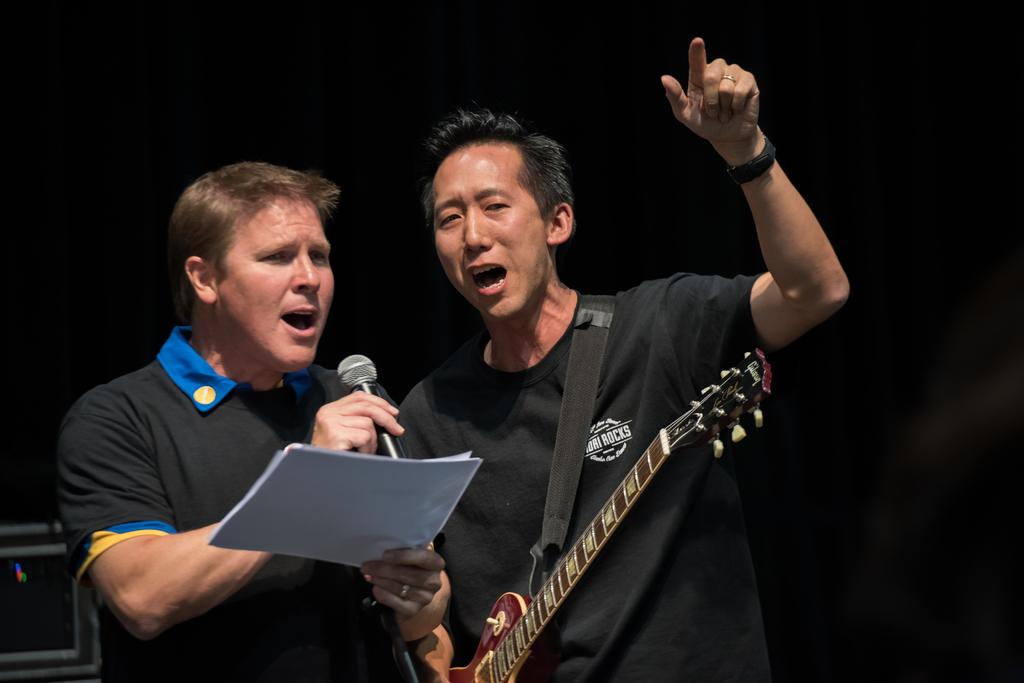Who or what is present in the image? There are people in the image. What are the people holding in the image? The people are holding guitars. What other object can be seen in the image? There is a microphone in the image. What type of humor can be seen in the image? There is no humor present in the image; it features people holding guitars and a microphone. Can you tell me how many rakes are visible in the image? There are no rakes present in the image. 